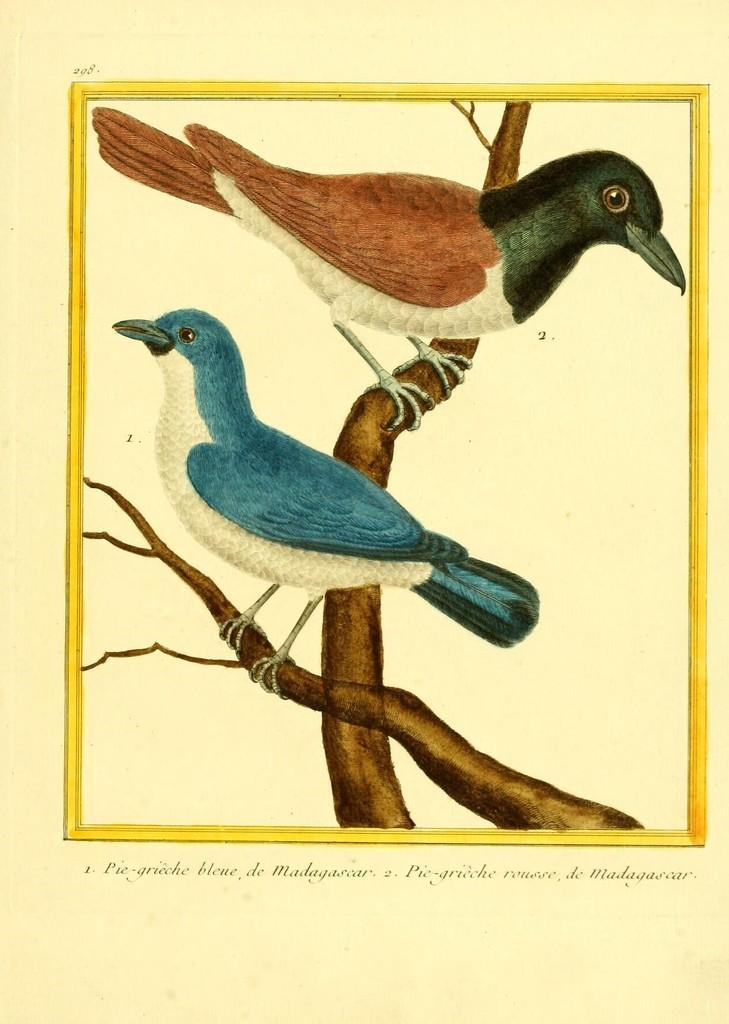In one or two sentences, can you explain what this image depicts? In this picture I can observe an art of two birds on the branches. The birds are in brown, black, white and blue colors. I can observe yellow color frame. The background is in cream color. 